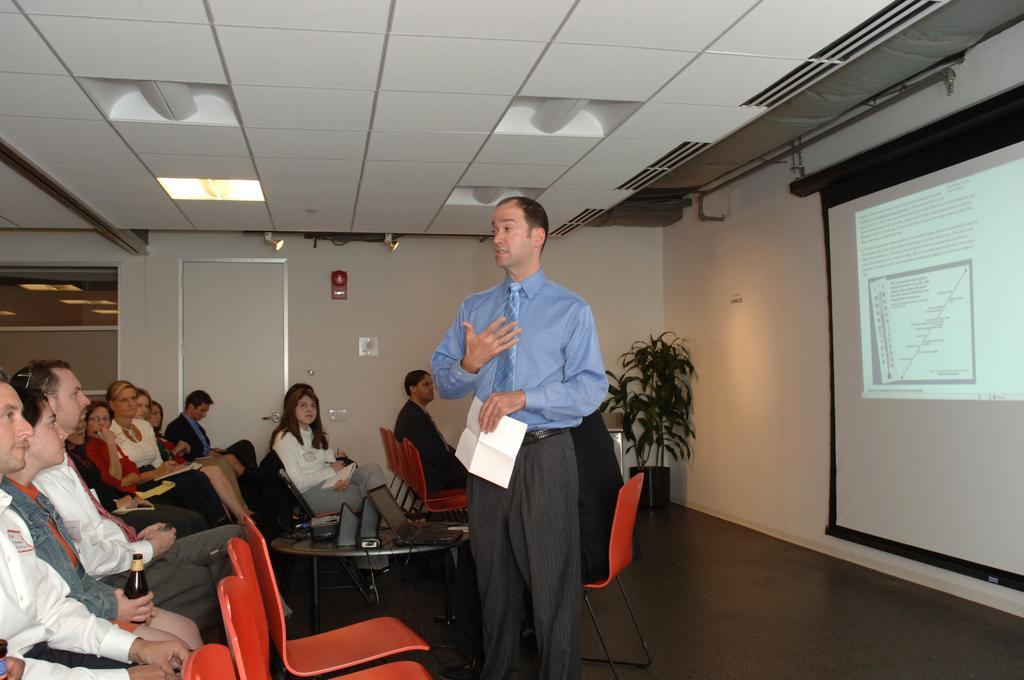Describe this image in one or two sentences. In this picture we can see a group of people sitting on chairs. In front of them we can see a man holding a paper with his hand, standing on the floor and the table with a laptop, cables and some objects on it. In the background we can see the walls, screen, houseplant, ceiling, door, lights and some objects. 